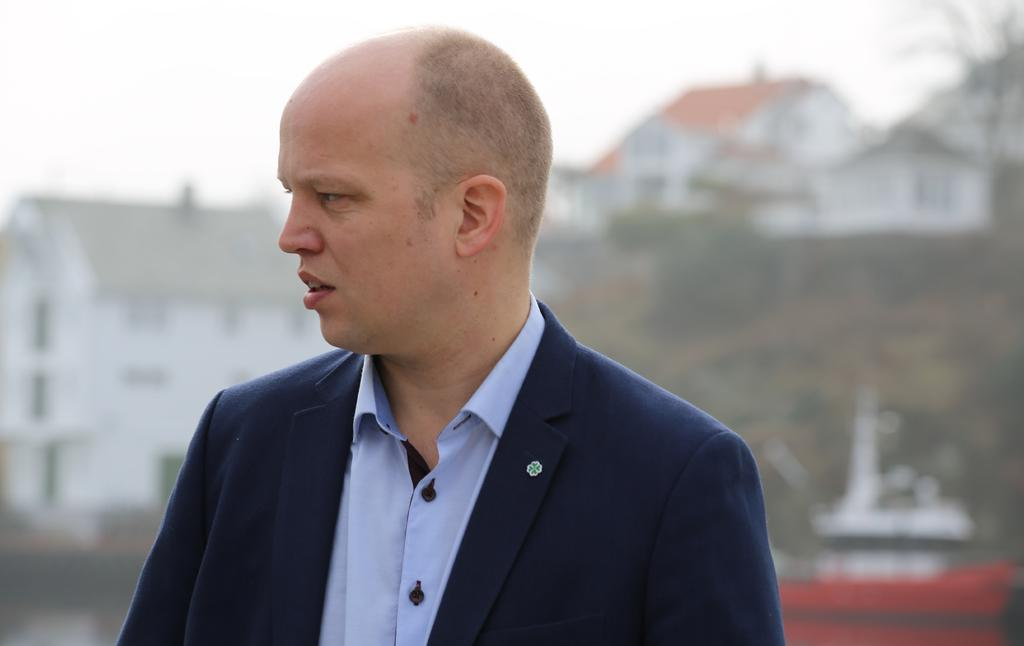Who or what is the main subject in the image? There is a person in the image. What can be seen in the background behind the person? There are buildings behind the person. Are there any natural elements present in the image? Yes, there are trees in the image. What type of grass is growing around the person in the image? There is no grass visible in the image; it features a person, buildings, and trees. 